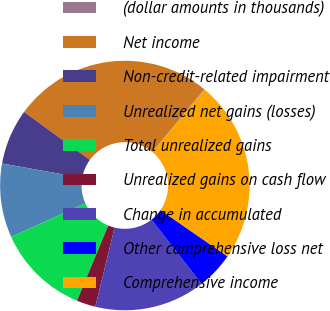<chart> <loc_0><loc_0><loc_500><loc_500><pie_chart><fcel>(dollar amounts in thousands)<fcel>Net income<fcel>Non-credit-related impairment<fcel>Unrealized net gains (losses)<fcel>Total unrealized gains<fcel>Unrealized gains on cash flow<fcel>Change in accumulated<fcel>Other comprehensive loss net<fcel>Comprehensive income<nl><fcel>0.08%<fcel>25.94%<fcel>7.21%<fcel>9.59%<fcel>11.97%<fcel>2.46%<fcel>14.35%<fcel>4.84%<fcel>23.56%<nl></chart> 